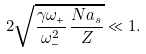Convert formula to latex. <formula><loc_0><loc_0><loc_500><loc_500>2 \sqrt { \frac { \gamma \omega _ { + } } { \omega _ { - } ^ { 2 } } \, \frac { N a _ { s } } { Z } } \ll 1 .</formula> 